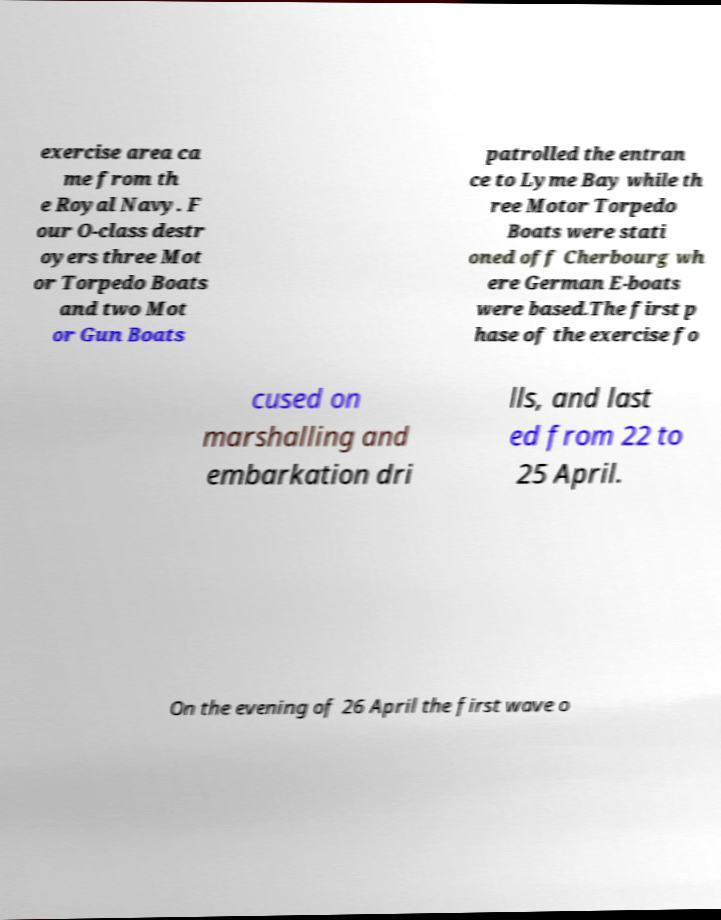Please read and relay the text visible in this image. What does it say? exercise area ca me from th e Royal Navy. F our O-class destr oyers three Mot or Torpedo Boats and two Mot or Gun Boats patrolled the entran ce to Lyme Bay while th ree Motor Torpedo Boats were stati oned off Cherbourg wh ere German E-boats were based.The first p hase of the exercise fo cused on marshalling and embarkation dri lls, and last ed from 22 to 25 April. On the evening of 26 April the first wave o 